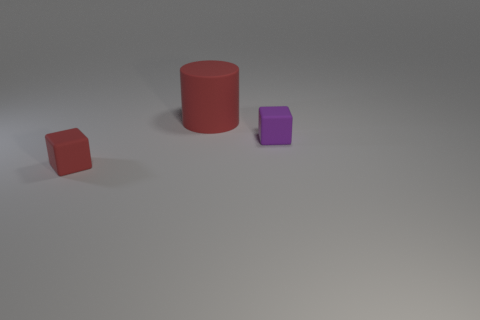There is another object that is the same shape as the small purple thing; what is it made of?
Offer a very short reply. Rubber. There is a small block to the right of the red matte object that is in front of the red cylinder; what is its material?
Offer a terse response. Rubber. Is the shape of the large object the same as the tiny object that is in front of the purple matte block?
Offer a terse response. No. How many rubber objects are red cylinders or big spheres?
Ensure brevity in your answer.  1. What color is the matte object that is right of the red thing right of the red object to the left of the red cylinder?
Provide a short and direct response. Purple. Does the tiny rubber object that is to the left of the small purple matte thing have the same shape as the large matte thing?
Ensure brevity in your answer.  No. What number of large things are either blocks or brown metallic blocks?
Your response must be concise. 0. Is the number of large red things to the right of the purple cube the same as the number of tiny purple objects that are on the left side of the big object?
Ensure brevity in your answer.  Yes. How many other objects are there of the same color as the big cylinder?
Offer a very short reply. 1. Is the color of the cylinder the same as the rubber thing to the left of the big red cylinder?
Ensure brevity in your answer.  Yes. 